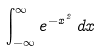Convert formula to latex. <formula><loc_0><loc_0><loc_500><loc_500>\int _ { - \infty } ^ { \infty } e ^ { - x ^ { 2 } } \, d x</formula> 